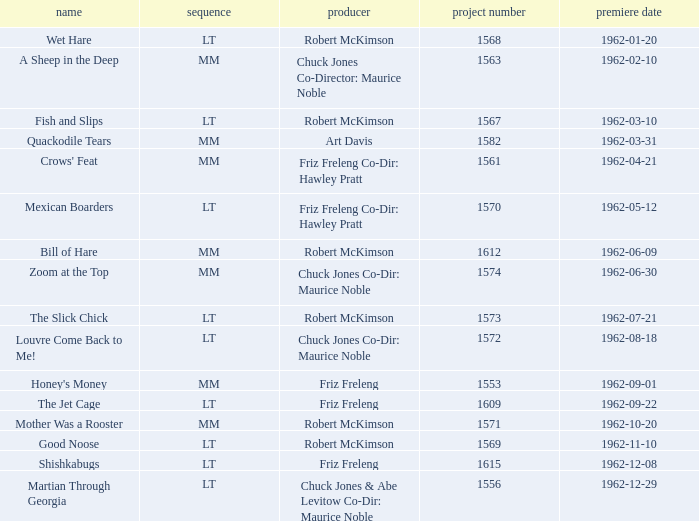What is Crows' Feat's production number? 1561.0. 